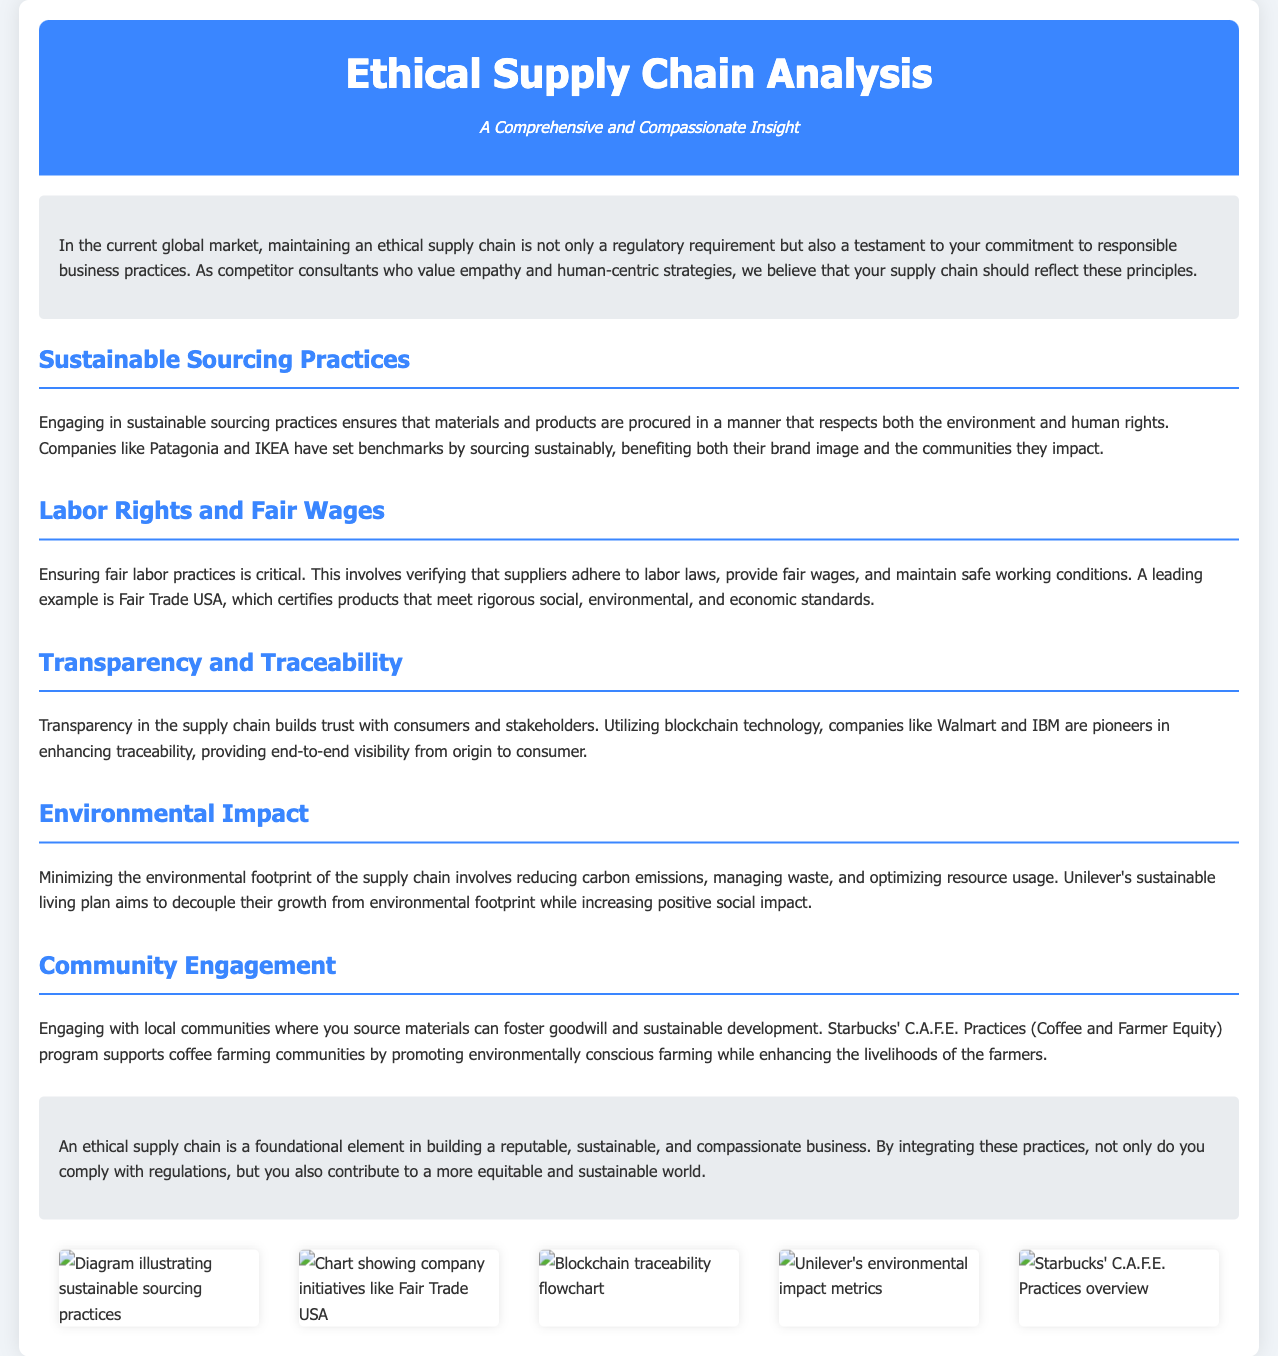What is the title of the document? The title of the document is prominently displayed at the top and is "Ethical Supply Chain Analysis."
Answer: Ethical Supply Chain Analysis Who is mentioned as a leading example of fair trade certification? The document references Fair Trade USA as a leading example for certifying products that meet rigorous standards.
Answer: Fair Trade USA What environmental initiative does Unilever have? Unilever's initiative mentioned is their sustainable living plan aimed at reducing their environmental footprint.
Answer: Sustainable living plan Which company is highlighted for using blockchain technology for traceability? The document highlights Walmart and IBM as pioneers in utilizing blockchain technology for supply chain traceability.
Answer: Walmart and IBM What community engagement program does Starbucks run? The document mentions Starbucks' C.A.F.E. Practices, which support coffee farming communities.
Answer: C.A.F.E. Practices Which company's sourcing practices are cited as sustainable? Patagonia and IKEA are cited as companies that have set benchmarks in sustainable sourcing practices.
Answer: Patagonia and IKEA What color is used for the header background? The document specifies that the header has a background color of #3a86ff (a shade of blue).
Answer: #3a86ff What is the purpose of the introduction section? The introduction emphasizes the importance of maintaining an ethical supply chain as a part of responsible business practices.
Answer: Responsible business practices How does the document describe the goal of community engagement? It describes that engaging with local communities fosters goodwill and sustainable development.
Answer: Goodwill and sustainable development 